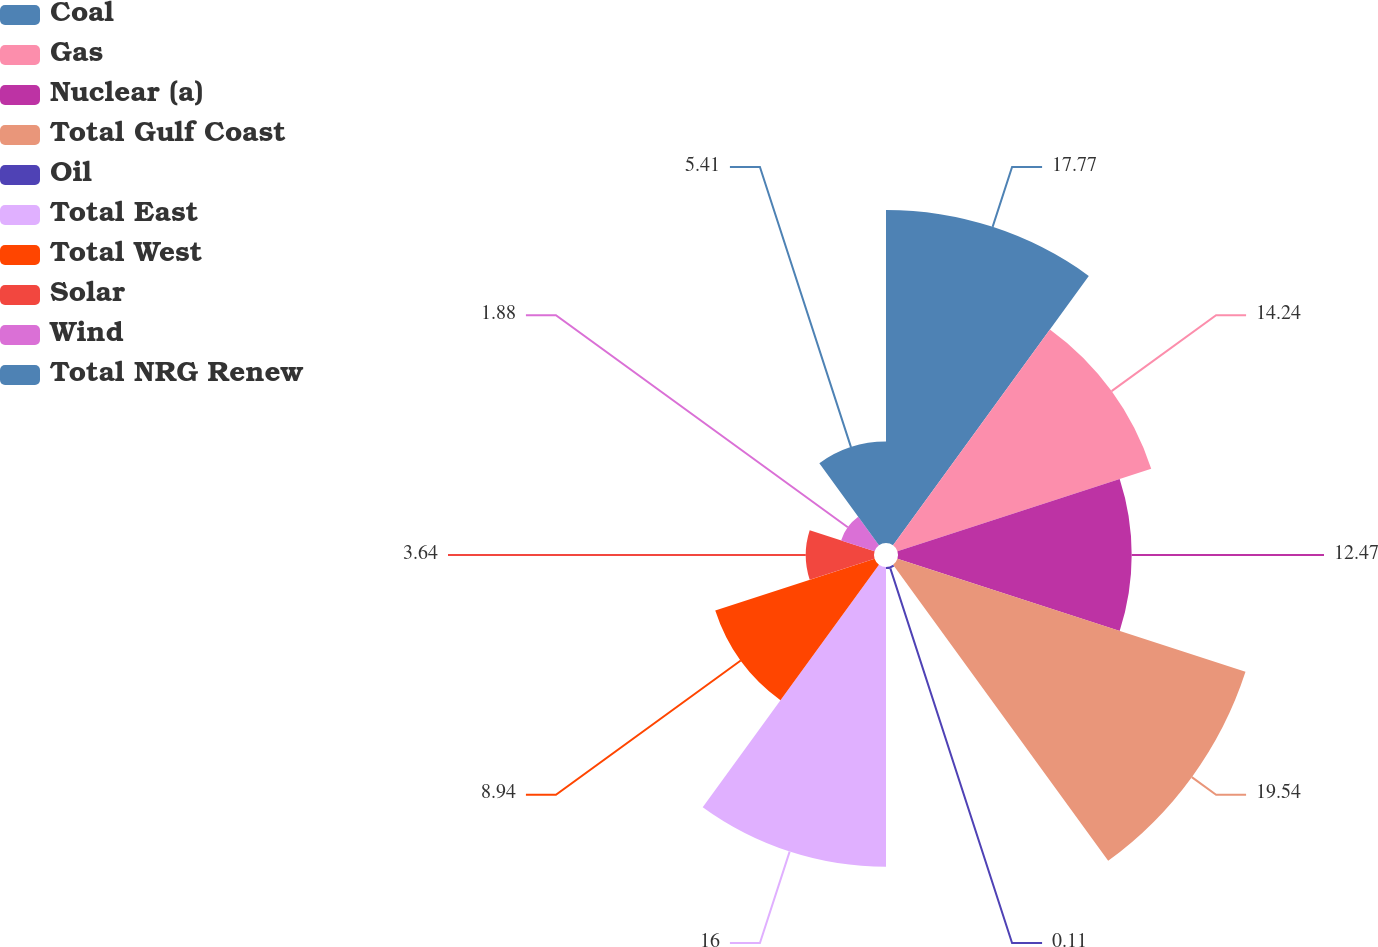Convert chart to OTSL. <chart><loc_0><loc_0><loc_500><loc_500><pie_chart><fcel>Coal<fcel>Gas<fcel>Nuclear (a)<fcel>Total Gulf Coast<fcel>Oil<fcel>Total East<fcel>Total West<fcel>Solar<fcel>Wind<fcel>Total NRG Renew<nl><fcel>17.77%<fcel>14.24%<fcel>12.47%<fcel>19.53%<fcel>0.11%<fcel>16.0%<fcel>8.94%<fcel>3.64%<fcel>1.88%<fcel>5.41%<nl></chart> 